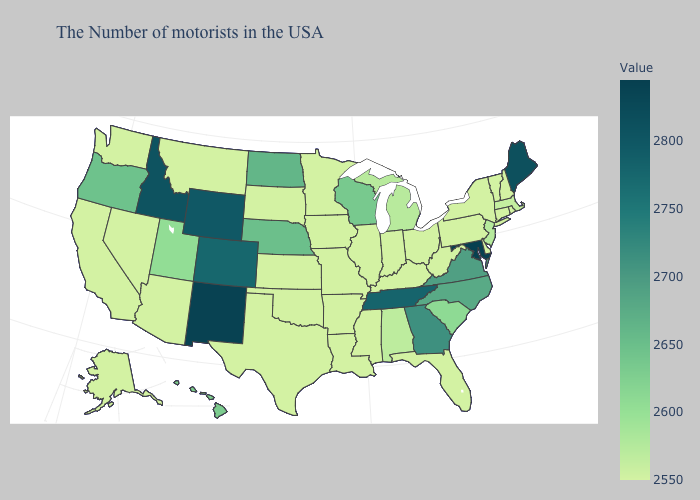Does Maryland have the highest value in the USA?
Short answer required. Yes. Among the states that border Idaho , does Nevada have the lowest value?
Answer briefly. Yes. Among the states that border Kansas , which have the highest value?
Concise answer only. Colorado. Among the states that border Michigan , does Ohio have the highest value?
Short answer required. No. Does the map have missing data?
Write a very short answer. No. 